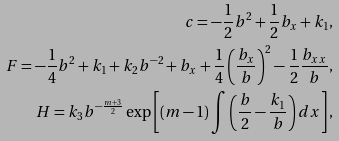Convert formula to latex. <formula><loc_0><loc_0><loc_500><loc_500>c = - \frac { 1 } { 2 } b ^ { 2 } + \frac { 1 } { 2 } b _ { x } + k _ { 1 } , \\ F = - \frac { 1 } { 4 } b ^ { 2 } + k _ { 1 } + k _ { 2 } b ^ { - 2 } + b _ { x } + \frac { 1 } { 4 } \left ( \frac { b _ { x } } b \right ) ^ { 2 } - \frac { 1 } { 2 } \frac { b _ { x x } } b , \\ H = k _ { 3 } b ^ { - \frac { m + 3 } 2 } \exp \left [ ( m - 1 ) \int \left ( \frac { b } { 2 } - \frac { k _ { 1 } } b \right ) d x \right ] ,</formula> 